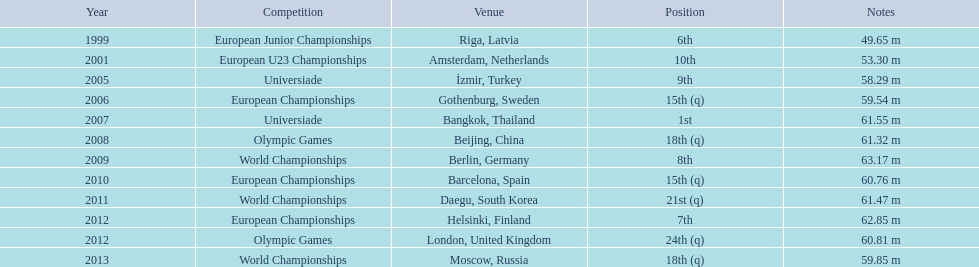In what years did gerhard mayer compete? 1999, 2001, 2005, 2006, 2007, 2008, 2009, 2010, 2011, 2012, 2012, 2013. Which of these years occurred prior to 2007? 1999, 2001, 2005, 2006. What was the top position attained during those years? 6th. 